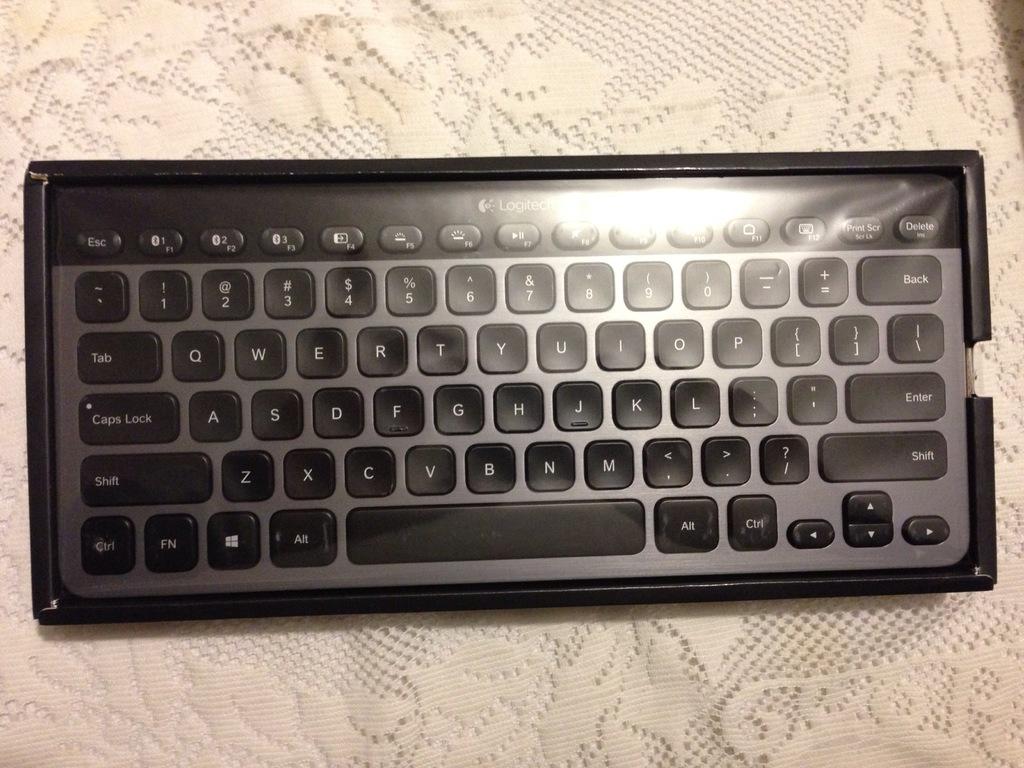What is this the first letter on the keyboard?
Your answer should be very brief. Q. What key is on the very bottom left?
Offer a terse response. Ctrl. 